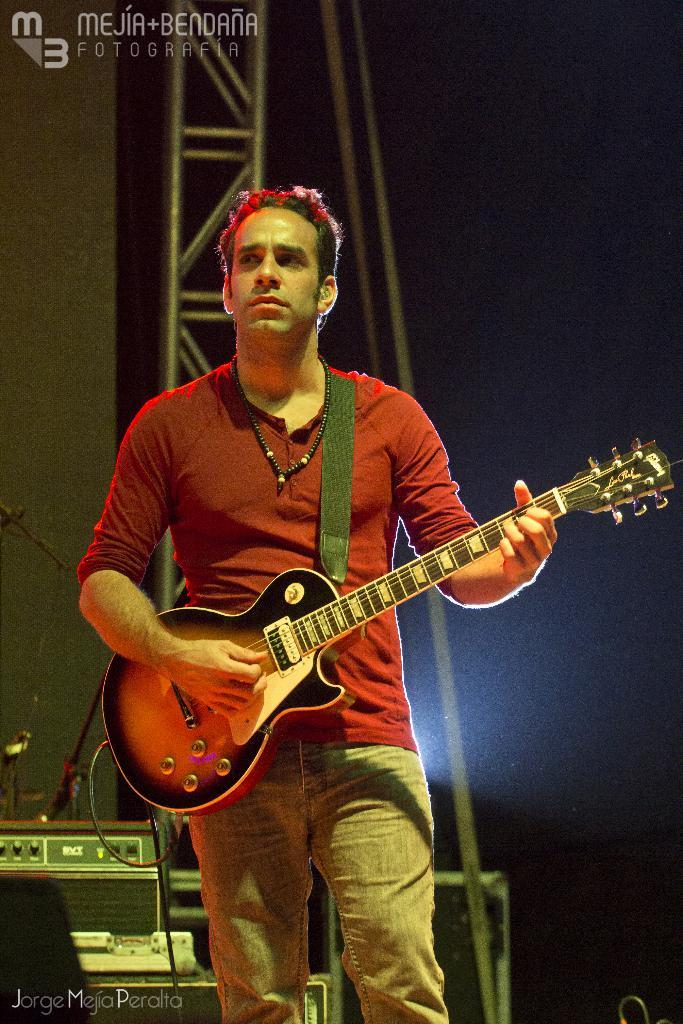What is the main subject of the image? The main subject of the image is a man. What is the man holding in his hand? The man is holding a guitar in his hand. What type of cake is being played on the marble surface in the image? There is no cake or marble surface present in the image; it features a man holding a guitar. 